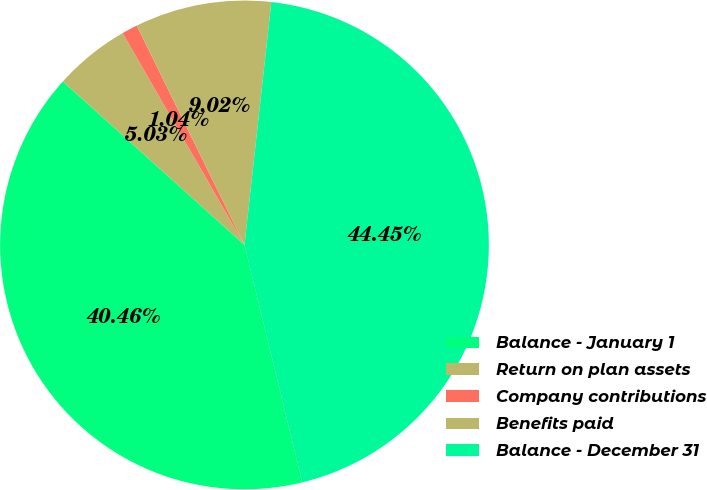Convert chart. <chart><loc_0><loc_0><loc_500><loc_500><pie_chart><fcel>Balance - January 1<fcel>Return on plan assets<fcel>Company contributions<fcel>Benefits paid<fcel>Balance - December 31<nl><fcel>40.46%<fcel>5.03%<fcel>1.04%<fcel>9.02%<fcel>44.45%<nl></chart> 